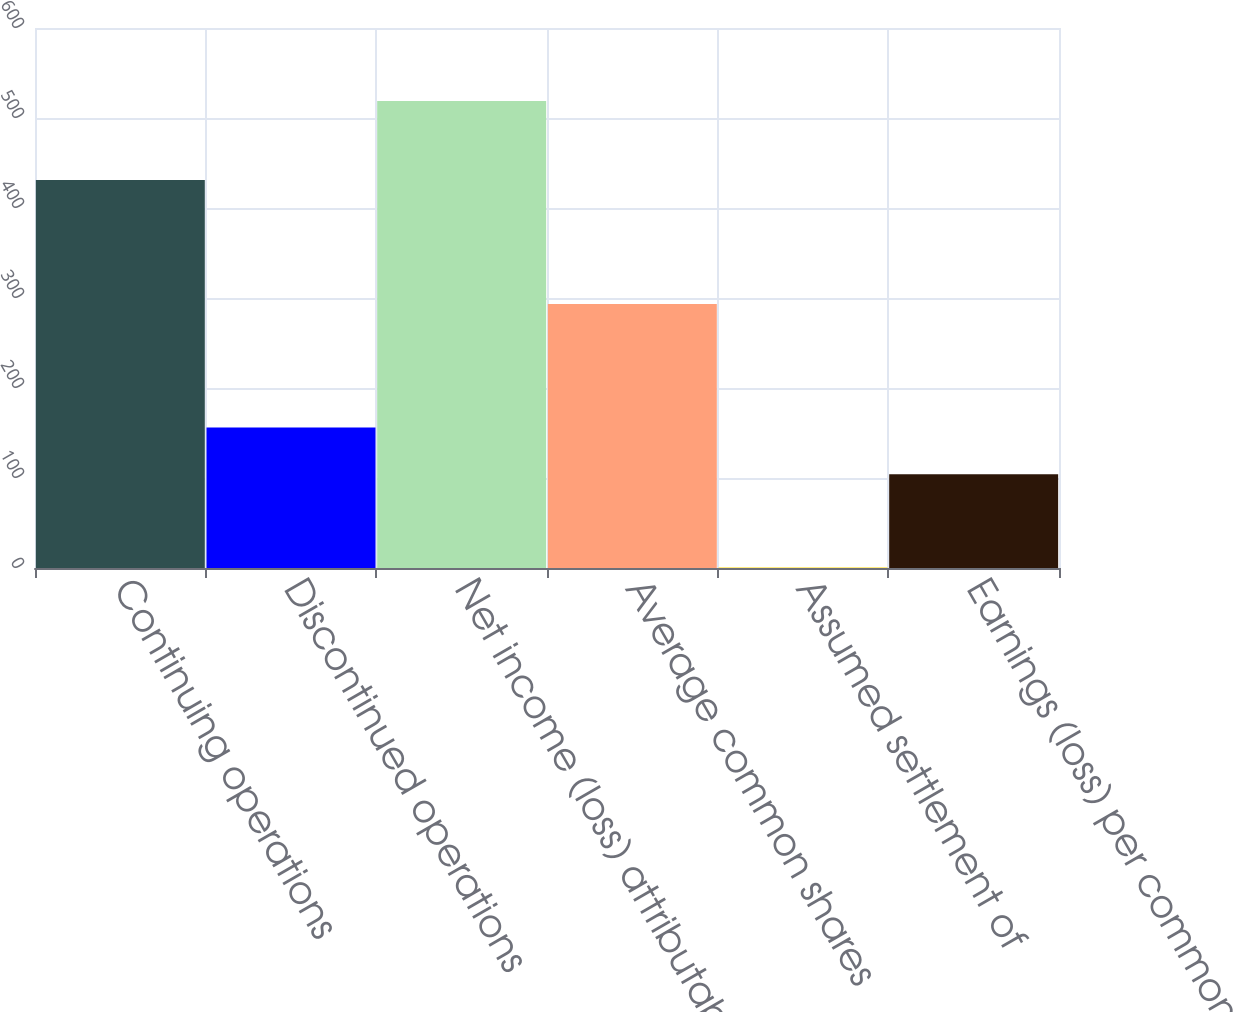<chart> <loc_0><loc_0><loc_500><loc_500><bar_chart><fcel>Continuing operations<fcel>Discontinued operations<fcel>Net income (loss) attributable<fcel>Average common shares<fcel>Assumed settlement of<fcel>Earnings (loss) per common<nl><fcel>431<fcel>156.12<fcel>519<fcel>293.34<fcel>0.6<fcel>104.28<nl></chart> 